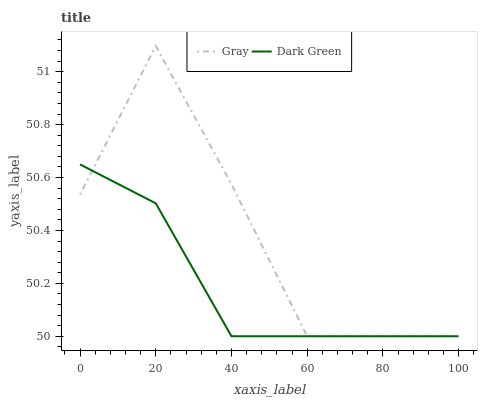Does Dark Green have the minimum area under the curve?
Answer yes or no. Yes. Does Gray have the maximum area under the curve?
Answer yes or no. Yes. Does Dark Green have the maximum area under the curve?
Answer yes or no. No. Is Dark Green the smoothest?
Answer yes or no. Yes. Is Gray the roughest?
Answer yes or no. Yes. Is Dark Green the roughest?
Answer yes or no. No. Does Gray have the lowest value?
Answer yes or no. Yes. Does Gray have the highest value?
Answer yes or no. Yes. Does Dark Green have the highest value?
Answer yes or no. No. Does Gray intersect Dark Green?
Answer yes or no. Yes. Is Gray less than Dark Green?
Answer yes or no. No. Is Gray greater than Dark Green?
Answer yes or no. No. 